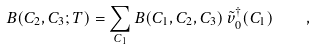Convert formula to latex. <formula><loc_0><loc_0><loc_500><loc_500>B ( C _ { 2 } , C _ { 3 } ; T ) = \sum _ { C _ { 1 } } B ( C _ { 1 } , C _ { 2 } , C _ { 3 } ) \, \tilde { v } _ { 0 } ^ { \dagger } ( C _ { 1 } ) \quad ,</formula> 